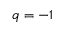<formula> <loc_0><loc_0><loc_500><loc_500>q = - 1</formula> 